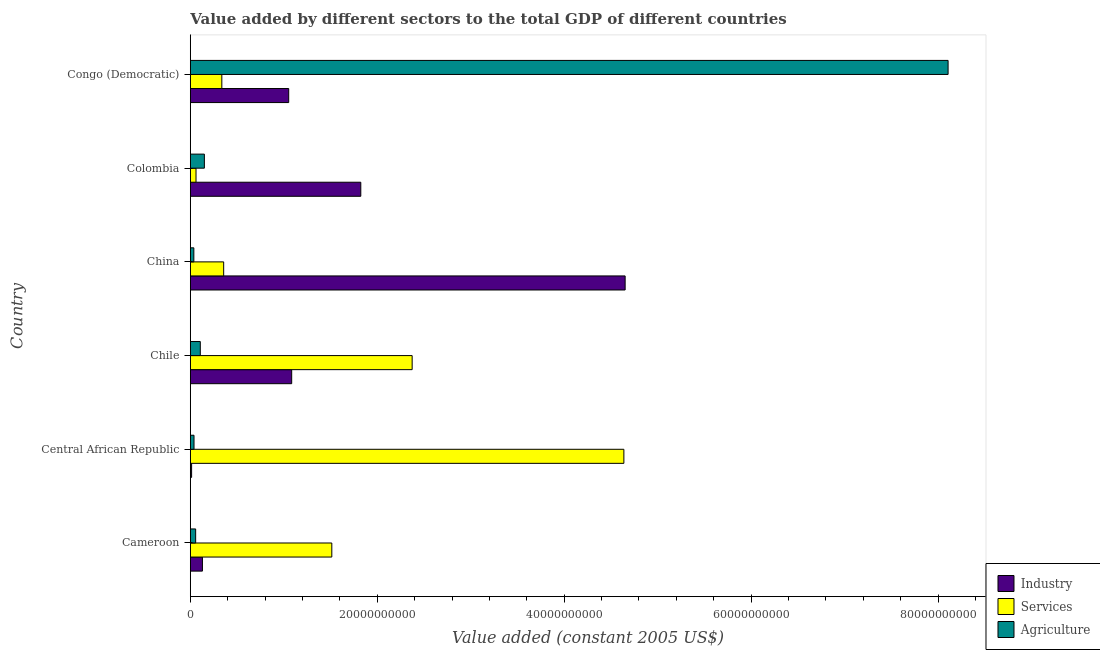How many different coloured bars are there?
Provide a succinct answer. 3. Are the number of bars per tick equal to the number of legend labels?
Ensure brevity in your answer.  Yes. What is the label of the 1st group of bars from the top?
Offer a terse response. Congo (Democratic). In how many cases, is the number of bars for a given country not equal to the number of legend labels?
Your answer should be compact. 0. What is the value added by industrial sector in China?
Offer a very short reply. 4.65e+1. Across all countries, what is the maximum value added by industrial sector?
Provide a succinct answer. 4.65e+1. Across all countries, what is the minimum value added by agricultural sector?
Your answer should be compact. 3.80e+08. In which country was the value added by services maximum?
Provide a succinct answer. Central African Republic. In which country was the value added by industrial sector minimum?
Your answer should be compact. Central African Republic. What is the total value added by agricultural sector in the graph?
Offer a terse response. 8.50e+1. What is the difference between the value added by services in China and that in Congo (Democratic)?
Keep it short and to the point. 1.99e+08. What is the difference between the value added by industrial sector in Cameroon and the value added by agricultural sector in Chile?
Provide a short and direct response. 2.28e+08. What is the average value added by agricultural sector per country?
Ensure brevity in your answer.  1.42e+1. What is the difference between the value added by agricultural sector and value added by industrial sector in China?
Ensure brevity in your answer.  -4.61e+1. In how many countries, is the value added by agricultural sector greater than 52000000000 US$?
Offer a very short reply. 1. What is the ratio of the value added by services in China to that in Congo (Democratic)?
Offer a terse response. 1.06. Is the value added by industrial sector in Central African Republic less than that in Chile?
Your response must be concise. Yes. What is the difference between the highest and the second highest value added by agricultural sector?
Offer a very short reply. 7.96e+1. What is the difference between the highest and the lowest value added by services?
Provide a short and direct response. 4.58e+1. Is the sum of the value added by services in Cameroon and China greater than the maximum value added by agricultural sector across all countries?
Your response must be concise. No. What does the 2nd bar from the top in Colombia represents?
Offer a very short reply. Services. What does the 3rd bar from the bottom in Colombia represents?
Ensure brevity in your answer.  Agriculture. How many bars are there?
Give a very brief answer. 18. How many countries are there in the graph?
Your answer should be compact. 6. What is the difference between two consecutive major ticks on the X-axis?
Make the answer very short. 2.00e+1. Are the values on the major ticks of X-axis written in scientific E-notation?
Your answer should be compact. No. Does the graph contain grids?
Offer a very short reply. No. Where does the legend appear in the graph?
Provide a succinct answer. Bottom right. How are the legend labels stacked?
Provide a succinct answer. Vertical. What is the title of the graph?
Your response must be concise. Value added by different sectors to the total GDP of different countries. Does "Ireland" appear as one of the legend labels in the graph?
Your response must be concise. No. What is the label or title of the X-axis?
Offer a terse response. Value added (constant 2005 US$). What is the label or title of the Y-axis?
Make the answer very short. Country. What is the Value added (constant 2005 US$) of Industry in Cameroon?
Your answer should be compact. 1.30e+09. What is the Value added (constant 2005 US$) of Services in Cameroon?
Provide a short and direct response. 1.51e+1. What is the Value added (constant 2005 US$) of Agriculture in Cameroon?
Provide a short and direct response. 5.74e+08. What is the Value added (constant 2005 US$) in Industry in Central African Republic?
Provide a short and direct response. 1.40e+08. What is the Value added (constant 2005 US$) in Services in Central African Republic?
Offer a terse response. 4.64e+1. What is the Value added (constant 2005 US$) of Agriculture in Central African Republic?
Provide a succinct answer. 3.98e+08. What is the Value added (constant 2005 US$) in Industry in Chile?
Your response must be concise. 1.08e+1. What is the Value added (constant 2005 US$) in Services in Chile?
Your answer should be compact. 2.37e+1. What is the Value added (constant 2005 US$) in Agriculture in Chile?
Provide a short and direct response. 1.07e+09. What is the Value added (constant 2005 US$) of Industry in China?
Offer a very short reply. 4.65e+1. What is the Value added (constant 2005 US$) of Services in China?
Provide a succinct answer. 3.57e+09. What is the Value added (constant 2005 US$) in Agriculture in China?
Your answer should be compact. 3.80e+08. What is the Value added (constant 2005 US$) in Industry in Colombia?
Provide a succinct answer. 1.82e+1. What is the Value added (constant 2005 US$) in Services in Colombia?
Ensure brevity in your answer.  6.12e+08. What is the Value added (constant 2005 US$) in Agriculture in Colombia?
Ensure brevity in your answer.  1.51e+09. What is the Value added (constant 2005 US$) in Industry in Congo (Democratic)?
Keep it short and to the point. 1.05e+1. What is the Value added (constant 2005 US$) of Services in Congo (Democratic)?
Your response must be concise. 3.37e+09. What is the Value added (constant 2005 US$) in Agriculture in Congo (Democratic)?
Ensure brevity in your answer.  8.11e+1. Across all countries, what is the maximum Value added (constant 2005 US$) of Industry?
Ensure brevity in your answer.  4.65e+1. Across all countries, what is the maximum Value added (constant 2005 US$) of Services?
Offer a very short reply. 4.64e+1. Across all countries, what is the maximum Value added (constant 2005 US$) in Agriculture?
Provide a succinct answer. 8.11e+1. Across all countries, what is the minimum Value added (constant 2005 US$) of Industry?
Ensure brevity in your answer.  1.40e+08. Across all countries, what is the minimum Value added (constant 2005 US$) in Services?
Give a very brief answer. 6.12e+08. Across all countries, what is the minimum Value added (constant 2005 US$) of Agriculture?
Provide a short and direct response. 3.80e+08. What is the total Value added (constant 2005 US$) of Industry in the graph?
Your answer should be very brief. 8.76e+1. What is the total Value added (constant 2005 US$) of Services in the graph?
Your answer should be compact. 9.28e+1. What is the total Value added (constant 2005 US$) of Agriculture in the graph?
Ensure brevity in your answer.  8.50e+1. What is the difference between the Value added (constant 2005 US$) of Industry in Cameroon and that in Central African Republic?
Your answer should be compact. 1.16e+09. What is the difference between the Value added (constant 2005 US$) of Services in Cameroon and that in Central African Republic?
Provide a short and direct response. -3.12e+1. What is the difference between the Value added (constant 2005 US$) of Agriculture in Cameroon and that in Central African Republic?
Keep it short and to the point. 1.75e+08. What is the difference between the Value added (constant 2005 US$) in Industry in Cameroon and that in Chile?
Provide a succinct answer. -9.55e+09. What is the difference between the Value added (constant 2005 US$) in Services in Cameroon and that in Chile?
Offer a very short reply. -8.60e+09. What is the difference between the Value added (constant 2005 US$) of Agriculture in Cameroon and that in Chile?
Ensure brevity in your answer.  -4.97e+08. What is the difference between the Value added (constant 2005 US$) of Industry in Cameroon and that in China?
Keep it short and to the point. -4.52e+1. What is the difference between the Value added (constant 2005 US$) of Services in Cameroon and that in China?
Ensure brevity in your answer.  1.16e+1. What is the difference between the Value added (constant 2005 US$) in Agriculture in Cameroon and that in China?
Your answer should be compact. 1.94e+08. What is the difference between the Value added (constant 2005 US$) in Industry in Cameroon and that in Colombia?
Make the answer very short. -1.69e+1. What is the difference between the Value added (constant 2005 US$) of Services in Cameroon and that in Colombia?
Offer a very short reply. 1.45e+1. What is the difference between the Value added (constant 2005 US$) of Agriculture in Cameroon and that in Colombia?
Offer a very short reply. -9.33e+08. What is the difference between the Value added (constant 2005 US$) in Industry in Cameroon and that in Congo (Democratic)?
Provide a succinct answer. -9.23e+09. What is the difference between the Value added (constant 2005 US$) in Services in Cameroon and that in Congo (Democratic)?
Provide a short and direct response. 1.18e+1. What is the difference between the Value added (constant 2005 US$) of Agriculture in Cameroon and that in Congo (Democratic)?
Your response must be concise. -8.05e+1. What is the difference between the Value added (constant 2005 US$) of Industry in Central African Republic and that in Chile?
Your answer should be compact. -1.07e+1. What is the difference between the Value added (constant 2005 US$) in Services in Central African Republic and that in Chile?
Your answer should be very brief. 2.27e+1. What is the difference between the Value added (constant 2005 US$) of Agriculture in Central African Republic and that in Chile?
Provide a succinct answer. -6.72e+08. What is the difference between the Value added (constant 2005 US$) in Industry in Central African Republic and that in China?
Provide a short and direct response. -4.64e+1. What is the difference between the Value added (constant 2005 US$) of Services in Central African Republic and that in China?
Make the answer very short. 4.28e+1. What is the difference between the Value added (constant 2005 US$) of Agriculture in Central African Republic and that in China?
Offer a very short reply. 1.84e+07. What is the difference between the Value added (constant 2005 US$) in Industry in Central African Republic and that in Colombia?
Your answer should be very brief. -1.81e+1. What is the difference between the Value added (constant 2005 US$) in Services in Central African Republic and that in Colombia?
Your answer should be compact. 4.58e+1. What is the difference between the Value added (constant 2005 US$) in Agriculture in Central African Republic and that in Colombia?
Your response must be concise. -1.11e+09. What is the difference between the Value added (constant 2005 US$) of Industry in Central African Republic and that in Congo (Democratic)?
Make the answer very short. -1.04e+1. What is the difference between the Value added (constant 2005 US$) in Services in Central African Republic and that in Congo (Democratic)?
Give a very brief answer. 4.30e+1. What is the difference between the Value added (constant 2005 US$) in Agriculture in Central African Republic and that in Congo (Democratic)?
Make the answer very short. -8.07e+1. What is the difference between the Value added (constant 2005 US$) in Industry in Chile and that in China?
Ensure brevity in your answer.  -3.57e+1. What is the difference between the Value added (constant 2005 US$) of Services in Chile and that in China?
Ensure brevity in your answer.  2.02e+1. What is the difference between the Value added (constant 2005 US$) of Agriculture in Chile and that in China?
Your answer should be compact. 6.90e+08. What is the difference between the Value added (constant 2005 US$) of Industry in Chile and that in Colombia?
Provide a succinct answer. -7.39e+09. What is the difference between the Value added (constant 2005 US$) of Services in Chile and that in Colombia?
Your answer should be compact. 2.31e+1. What is the difference between the Value added (constant 2005 US$) in Agriculture in Chile and that in Colombia?
Your response must be concise. -4.36e+08. What is the difference between the Value added (constant 2005 US$) of Industry in Chile and that in Congo (Democratic)?
Your response must be concise. 3.19e+08. What is the difference between the Value added (constant 2005 US$) of Services in Chile and that in Congo (Democratic)?
Offer a terse response. 2.04e+1. What is the difference between the Value added (constant 2005 US$) of Agriculture in Chile and that in Congo (Democratic)?
Keep it short and to the point. -8.00e+1. What is the difference between the Value added (constant 2005 US$) of Industry in China and that in Colombia?
Keep it short and to the point. 2.83e+1. What is the difference between the Value added (constant 2005 US$) of Services in China and that in Colombia?
Make the answer very short. 2.96e+09. What is the difference between the Value added (constant 2005 US$) of Agriculture in China and that in Colombia?
Keep it short and to the point. -1.13e+09. What is the difference between the Value added (constant 2005 US$) of Industry in China and that in Congo (Democratic)?
Your response must be concise. 3.60e+1. What is the difference between the Value added (constant 2005 US$) of Services in China and that in Congo (Democratic)?
Provide a succinct answer. 1.99e+08. What is the difference between the Value added (constant 2005 US$) in Agriculture in China and that in Congo (Democratic)?
Offer a very short reply. -8.07e+1. What is the difference between the Value added (constant 2005 US$) in Industry in Colombia and that in Congo (Democratic)?
Provide a short and direct response. 7.71e+09. What is the difference between the Value added (constant 2005 US$) in Services in Colombia and that in Congo (Democratic)?
Offer a very short reply. -2.76e+09. What is the difference between the Value added (constant 2005 US$) in Agriculture in Colombia and that in Congo (Democratic)?
Keep it short and to the point. -7.96e+1. What is the difference between the Value added (constant 2005 US$) in Industry in Cameroon and the Value added (constant 2005 US$) in Services in Central African Republic?
Offer a terse response. -4.51e+1. What is the difference between the Value added (constant 2005 US$) of Industry in Cameroon and the Value added (constant 2005 US$) of Agriculture in Central African Republic?
Your answer should be very brief. 9.00e+08. What is the difference between the Value added (constant 2005 US$) of Services in Cameroon and the Value added (constant 2005 US$) of Agriculture in Central African Republic?
Keep it short and to the point. 1.47e+1. What is the difference between the Value added (constant 2005 US$) of Industry in Cameroon and the Value added (constant 2005 US$) of Services in Chile?
Make the answer very short. -2.24e+1. What is the difference between the Value added (constant 2005 US$) in Industry in Cameroon and the Value added (constant 2005 US$) in Agriculture in Chile?
Keep it short and to the point. 2.28e+08. What is the difference between the Value added (constant 2005 US$) of Services in Cameroon and the Value added (constant 2005 US$) of Agriculture in Chile?
Provide a succinct answer. 1.41e+1. What is the difference between the Value added (constant 2005 US$) in Industry in Cameroon and the Value added (constant 2005 US$) in Services in China?
Offer a very short reply. -2.27e+09. What is the difference between the Value added (constant 2005 US$) in Industry in Cameroon and the Value added (constant 2005 US$) in Agriculture in China?
Provide a short and direct response. 9.19e+08. What is the difference between the Value added (constant 2005 US$) in Services in Cameroon and the Value added (constant 2005 US$) in Agriculture in China?
Make the answer very short. 1.48e+1. What is the difference between the Value added (constant 2005 US$) of Industry in Cameroon and the Value added (constant 2005 US$) of Services in Colombia?
Ensure brevity in your answer.  6.86e+08. What is the difference between the Value added (constant 2005 US$) in Industry in Cameroon and the Value added (constant 2005 US$) in Agriculture in Colombia?
Offer a very short reply. -2.08e+08. What is the difference between the Value added (constant 2005 US$) in Services in Cameroon and the Value added (constant 2005 US$) in Agriculture in Colombia?
Offer a very short reply. 1.36e+1. What is the difference between the Value added (constant 2005 US$) of Industry in Cameroon and the Value added (constant 2005 US$) of Services in Congo (Democratic)?
Your response must be concise. -2.07e+09. What is the difference between the Value added (constant 2005 US$) of Industry in Cameroon and the Value added (constant 2005 US$) of Agriculture in Congo (Democratic)?
Provide a succinct answer. -7.98e+1. What is the difference between the Value added (constant 2005 US$) of Services in Cameroon and the Value added (constant 2005 US$) of Agriculture in Congo (Democratic)?
Offer a terse response. -6.59e+1. What is the difference between the Value added (constant 2005 US$) of Industry in Central African Republic and the Value added (constant 2005 US$) of Services in Chile?
Provide a short and direct response. -2.36e+1. What is the difference between the Value added (constant 2005 US$) of Industry in Central African Republic and the Value added (constant 2005 US$) of Agriculture in Chile?
Provide a succinct answer. -9.30e+08. What is the difference between the Value added (constant 2005 US$) of Services in Central African Republic and the Value added (constant 2005 US$) of Agriculture in Chile?
Provide a short and direct response. 4.53e+1. What is the difference between the Value added (constant 2005 US$) in Industry in Central African Republic and the Value added (constant 2005 US$) in Services in China?
Provide a succinct answer. -3.43e+09. What is the difference between the Value added (constant 2005 US$) in Industry in Central African Republic and the Value added (constant 2005 US$) in Agriculture in China?
Provide a succinct answer. -2.40e+08. What is the difference between the Value added (constant 2005 US$) in Services in Central African Republic and the Value added (constant 2005 US$) in Agriculture in China?
Your answer should be very brief. 4.60e+1. What is the difference between the Value added (constant 2005 US$) in Industry in Central African Republic and the Value added (constant 2005 US$) in Services in Colombia?
Give a very brief answer. -4.72e+08. What is the difference between the Value added (constant 2005 US$) of Industry in Central African Republic and the Value added (constant 2005 US$) of Agriculture in Colombia?
Your answer should be compact. -1.37e+09. What is the difference between the Value added (constant 2005 US$) in Services in Central African Republic and the Value added (constant 2005 US$) in Agriculture in Colombia?
Your response must be concise. 4.49e+1. What is the difference between the Value added (constant 2005 US$) in Industry in Central African Republic and the Value added (constant 2005 US$) in Services in Congo (Democratic)?
Make the answer very short. -3.23e+09. What is the difference between the Value added (constant 2005 US$) in Industry in Central African Republic and the Value added (constant 2005 US$) in Agriculture in Congo (Democratic)?
Ensure brevity in your answer.  -8.09e+1. What is the difference between the Value added (constant 2005 US$) of Services in Central African Republic and the Value added (constant 2005 US$) of Agriculture in Congo (Democratic)?
Keep it short and to the point. -3.47e+1. What is the difference between the Value added (constant 2005 US$) in Industry in Chile and the Value added (constant 2005 US$) in Services in China?
Provide a succinct answer. 7.28e+09. What is the difference between the Value added (constant 2005 US$) of Industry in Chile and the Value added (constant 2005 US$) of Agriculture in China?
Offer a terse response. 1.05e+1. What is the difference between the Value added (constant 2005 US$) of Services in Chile and the Value added (constant 2005 US$) of Agriculture in China?
Make the answer very short. 2.34e+1. What is the difference between the Value added (constant 2005 US$) of Industry in Chile and the Value added (constant 2005 US$) of Services in Colombia?
Make the answer very short. 1.02e+1. What is the difference between the Value added (constant 2005 US$) in Industry in Chile and the Value added (constant 2005 US$) in Agriculture in Colombia?
Keep it short and to the point. 9.34e+09. What is the difference between the Value added (constant 2005 US$) of Services in Chile and the Value added (constant 2005 US$) of Agriculture in Colombia?
Provide a succinct answer. 2.22e+1. What is the difference between the Value added (constant 2005 US$) of Industry in Chile and the Value added (constant 2005 US$) of Services in Congo (Democratic)?
Give a very brief answer. 7.47e+09. What is the difference between the Value added (constant 2005 US$) of Industry in Chile and the Value added (constant 2005 US$) of Agriculture in Congo (Democratic)?
Your answer should be compact. -7.02e+1. What is the difference between the Value added (constant 2005 US$) of Services in Chile and the Value added (constant 2005 US$) of Agriculture in Congo (Democratic)?
Offer a terse response. -5.73e+1. What is the difference between the Value added (constant 2005 US$) of Industry in China and the Value added (constant 2005 US$) of Services in Colombia?
Your answer should be very brief. 4.59e+1. What is the difference between the Value added (constant 2005 US$) in Industry in China and the Value added (constant 2005 US$) in Agriculture in Colombia?
Your response must be concise. 4.50e+1. What is the difference between the Value added (constant 2005 US$) of Services in China and the Value added (constant 2005 US$) of Agriculture in Colombia?
Your answer should be compact. 2.07e+09. What is the difference between the Value added (constant 2005 US$) in Industry in China and the Value added (constant 2005 US$) in Services in Congo (Democratic)?
Provide a succinct answer. 4.31e+1. What is the difference between the Value added (constant 2005 US$) in Industry in China and the Value added (constant 2005 US$) in Agriculture in Congo (Democratic)?
Provide a short and direct response. -3.46e+1. What is the difference between the Value added (constant 2005 US$) of Services in China and the Value added (constant 2005 US$) of Agriculture in Congo (Democratic)?
Ensure brevity in your answer.  -7.75e+1. What is the difference between the Value added (constant 2005 US$) in Industry in Colombia and the Value added (constant 2005 US$) in Services in Congo (Democratic)?
Provide a short and direct response. 1.49e+1. What is the difference between the Value added (constant 2005 US$) in Industry in Colombia and the Value added (constant 2005 US$) in Agriculture in Congo (Democratic)?
Provide a short and direct response. -6.28e+1. What is the difference between the Value added (constant 2005 US$) in Services in Colombia and the Value added (constant 2005 US$) in Agriculture in Congo (Democratic)?
Your answer should be compact. -8.05e+1. What is the average Value added (constant 2005 US$) of Industry per country?
Your answer should be very brief. 1.46e+1. What is the average Value added (constant 2005 US$) of Services per country?
Offer a very short reply. 1.55e+1. What is the average Value added (constant 2005 US$) of Agriculture per country?
Give a very brief answer. 1.42e+1. What is the difference between the Value added (constant 2005 US$) in Industry and Value added (constant 2005 US$) in Services in Cameroon?
Give a very brief answer. -1.38e+1. What is the difference between the Value added (constant 2005 US$) of Industry and Value added (constant 2005 US$) of Agriculture in Cameroon?
Make the answer very short. 7.25e+08. What is the difference between the Value added (constant 2005 US$) in Services and Value added (constant 2005 US$) in Agriculture in Cameroon?
Your response must be concise. 1.46e+1. What is the difference between the Value added (constant 2005 US$) in Industry and Value added (constant 2005 US$) in Services in Central African Republic?
Offer a very short reply. -4.62e+1. What is the difference between the Value added (constant 2005 US$) of Industry and Value added (constant 2005 US$) of Agriculture in Central African Republic?
Your answer should be very brief. -2.58e+08. What is the difference between the Value added (constant 2005 US$) of Services and Value added (constant 2005 US$) of Agriculture in Central African Republic?
Ensure brevity in your answer.  4.60e+1. What is the difference between the Value added (constant 2005 US$) in Industry and Value added (constant 2005 US$) in Services in Chile?
Give a very brief answer. -1.29e+1. What is the difference between the Value added (constant 2005 US$) in Industry and Value added (constant 2005 US$) in Agriculture in Chile?
Keep it short and to the point. 9.78e+09. What is the difference between the Value added (constant 2005 US$) of Services and Value added (constant 2005 US$) of Agriculture in Chile?
Your answer should be very brief. 2.27e+1. What is the difference between the Value added (constant 2005 US$) of Industry and Value added (constant 2005 US$) of Services in China?
Keep it short and to the point. 4.30e+1. What is the difference between the Value added (constant 2005 US$) of Industry and Value added (constant 2005 US$) of Agriculture in China?
Your answer should be compact. 4.61e+1. What is the difference between the Value added (constant 2005 US$) of Services and Value added (constant 2005 US$) of Agriculture in China?
Offer a terse response. 3.19e+09. What is the difference between the Value added (constant 2005 US$) of Industry and Value added (constant 2005 US$) of Services in Colombia?
Make the answer very short. 1.76e+1. What is the difference between the Value added (constant 2005 US$) in Industry and Value added (constant 2005 US$) in Agriculture in Colombia?
Your answer should be compact. 1.67e+1. What is the difference between the Value added (constant 2005 US$) in Services and Value added (constant 2005 US$) in Agriculture in Colombia?
Provide a succinct answer. -8.94e+08. What is the difference between the Value added (constant 2005 US$) in Industry and Value added (constant 2005 US$) in Services in Congo (Democratic)?
Make the answer very short. 7.16e+09. What is the difference between the Value added (constant 2005 US$) in Industry and Value added (constant 2005 US$) in Agriculture in Congo (Democratic)?
Your response must be concise. -7.05e+1. What is the difference between the Value added (constant 2005 US$) in Services and Value added (constant 2005 US$) in Agriculture in Congo (Democratic)?
Your answer should be compact. -7.77e+1. What is the ratio of the Value added (constant 2005 US$) of Industry in Cameroon to that in Central African Republic?
Your answer should be compact. 9.28. What is the ratio of the Value added (constant 2005 US$) of Services in Cameroon to that in Central African Republic?
Provide a succinct answer. 0.33. What is the ratio of the Value added (constant 2005 US$) in Agriculture in Cameroon to that in Central African Republic?
Provide a succinct answer. 1.44. What is the ratio of the Value added (constant 2005 US$) of Industry in Cameroon to that in Chile?
Offer a very short reply. 0.12. What is the ratio of the Value added (constant 2005 US$) of Services in Cameroon to that in Chile?
Provide a short and direct response. 0.64. What is the ratio of the Value added (constant 2005 US$) of Agriculture in Cameroon to that in Chile?
Offer a very short reply. 0.54. What is the ratio of the Value added (constant 2005 US$) in Industry in Cameroon to that in China?
Keep it short and to the point. 0.03. What is the ratio of the Value added (constant 2005 US$) in Services in Cameroon to that in China?
Offer a very short reply. 4.24. What is the ratio of the Value added (constant 2005 US$) in Agriculture in Cameroon to that in China?
Keep it short and to the point. 1.51. What is the ratio of the Value added (constant 2005 US$) in Industry in Cameroon to that in Colombia?
Provide a short and direct response. 0.07. What is the ratio of the Value added (constant 2005 US$) in Services in Cameroon to that in Colombia?
Your answer should be very brief. 24.74. What is the ratio of the Value added (constant 2005 US$) in Agriculture in Cameroon to that in Colombia?
Provide a succinct answer. 0.38. What is the ratio of the Value added (constant 2005 US$) in Industry in Cameroon to that in Congo (Democratic)?
Your response must be concise. 0.12. What is the ratio of the Value added (constant 2005 US$) in Services in Cameroon to that in Congo (Democratic)?
Provide a short and direct response. 4.49. What is the ratio of the Value added (constant 2005 US$) in Agriculture in Cameroon to that in Congo (Democratic)?
Provide a short and direct response. 0.01. What is the ratio of the Value added (constant 2005 US$) of Industry in Central African Republic to that in Chile?
Make the answer very short. 0.01. What is the ratio of the Value added (constant 2005 US$) in Services in Central African Republic to that in Chile?
Give a very brief answer. 1.95. What is the ratio of the Value added (constant 2005 US$) of Agriculture in Central African Republic to that in Chile?
Ensure brevity in your answer.  0.37. What is the ratio of the Value added (constant 2005 US$) in Industry in Central African Republic to that in China?
Your answer should be compact. 0. What is the ratio of the Value added (constant 2005 US$) in Services in Central African Republic to that in China?
Ensure brevity in your answer.  12.99. What is the ratio of the Value added (constant 2005 US$) in Agriculture in Central African Republic to that in China?
Offer a very short reply. 1.05. What is the ratio of the Value added (constant 2005 US$) in Industry in Central African Republic to that in Colombia?
Provide a succinct answer. 0.01. What is the ratio of the Value added (constant 2005 US$) in Services in Central African Republic to that in Colombia?
Your response must be concise. 75.79. What is the ratio of the Value added (constant 2005 US$) in Agriculture in Central African Republic to that in Colombia?
Make the answer very short. 0.26. What is the ratio of the Value added (constant 2005 US$) of Industry in Central African Republic to that in Congo (Democratic)?
Give a very brief answer. 0.01. What is the ratio of the Value added (constant 2005 US$) in Services in Central African Republic to that in Congo (Democratic)?
Provide a short and direct response. 13.75. What is the ratio of the Value added (constant 2005 US$) of Agriculture in Central African Republic to that in Congo (Democratic)?
Provide a succinct answer. 0. What is the ratio of the Value added (constant 2005 US$) of Industry in Chile to that in China?
Provide a succinct answer. 0.23. What is the ratio of the Value added (constant 2005 US$) in Services in Chile to that in China?
Provide a succinct answer. 6.65. What is the ratio of the Value added (constant 2005 US$) of Agriculture in Chile to that in China?
Provide a succinct answer. 2.82. What is the ratio of the Value added (constant 2005 US$) in Industry in Chile to that in Colombia?
Provide a short and direct response. 0.59. What is the ratio of the Value added (constant 2005 US$) in Services in Chile to that in Colombia?
Make the answer very short. 38.78. What is the ratio of the Value added (constant 2005 US$) of Agriculture in Chile to that in Colombia?
Provide a succinct answer. 0.71. What is the ratio of the Value added (constant 2005 US$) in Industry in Chile to that in Congo (Democratic)?
Your answer should be very brief. 1.03. What is the ratio of the Value added (constant 2005 US$) in Services in Chile to that in Congo (Democratic)?
Offer a terse response. 7.04. What is the ratio of the Value added (constant 2005 US$) in Agriculture in Chile to that in Congo (Democratic)?
Offer a very short reply. 0.01. What is the ratio of the Value added (constant 2005 US$) in Industry in China to that in Colombia?
Your answer should be very brief. 2.55. What is the ratio of the Value added (constant 2005 US$) in Services in China to that in Colombia?
Provide a short and direct response. 5.84. What is the ratio of the Value added (constant 2005 US$) in Agriculture in China to that in Colombia?
Keep it short and to the point. 0.25. What is the ratio of the Value added (constant 2005 US$) of Industry in China to that in Congo (Democratic)?
Your response must be concise. 4.42. What is the ratio of the Value added (constant 2005 US$) of Services in China to that in Congo (Democratic)?
Provide a succinct answer. 1.06. What is the ratio of the Value added (constant 2005 US$) of Agriculture in China to that in Congo (Democratic)?
Offer a terse response. 0. What is the ratio of the Value added (constant 2005 US$) of Industry in Colombia to that in Congo (Democratic)?
Your answer should be compact. 1.73. What is the ratio of the Value added (constant 2005 US$) in Services in Colombia to that in Congo (Democratic)?
Provide a succinct answer. 0.18. What is the ratio of the Value added (constant 2005 US$) in Agriculture in Colombia to that in Congo (Democratic)?
Make the answer very short. 0.02. What is the difference between the highest and the second highest Value added (constant 2005 US$) of Industry?
Ensure brevity in your answer.  2.83e+1. What is the difference between the highest and the second highest Value added (constant 2005 US$) in Services?
Give a very brief answer. 2.27e+1. What is the difference between the highest and the second highest Value added (constant 2005 US$) in Agriculture?
Ensure brevity in your answer.  7.96e+1. What is the difference between the highest and the lowest Value added (constant 2005 US$) of Industry?
Offer a very short reply. 4.64e+1. What is the difference between the highest and the lowest Value added (constant 2005 US$) in Services?
Your answer should be compact. 4.58e+1. What is the difference between the highest and the lowest Value added (constant 2005 US$) in Agriculture?
Keep it short and to the point. 8.07e+1. 